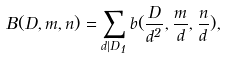Convert formula to latex. <formula><loc_0><loc_0><loc_500><loc_500>B ( D , m , n ) = \sum _ { d | D _ { 1 } } b ( \frac { D } { d ^ { 2 } } , \frac { m } { d } , \frac { n } { d } ) ,</formula> 